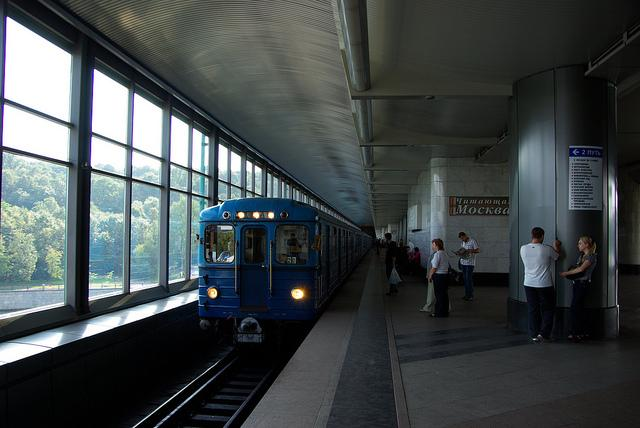What country is this location?

Choices:
A) russia
B) moldova
C) ukraine
D) belarus russia 